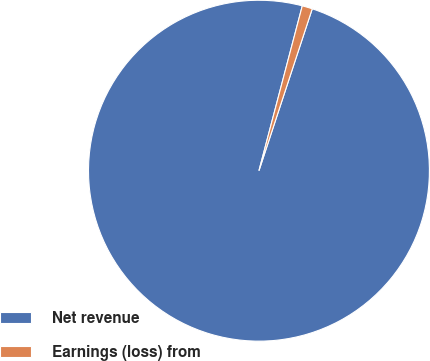<chart> <loc_0><loc_0><loc_500><loc_500><pie_chart><fcel>Net revenue<fcel>Earnings (loss) from<nl><fcel>99.03%<fcel>0.97%<nl></chart> 